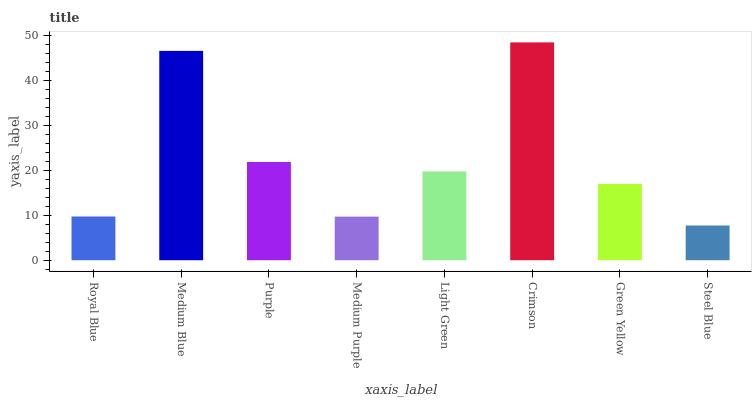Is Medium Blue the minimum?
Answer yes or no. No. Is Medium Blue the maximum?
Answer yes or no. No. Is Medium Blue greater than Royal Blue?
Answer yes or no. Yes. Is Royal Blue less than Medium Blue?
Answer yes or no. Yes. Is Royal Blue greater than Medium Blue?
Answer yes or no. No. Is Medium Blue less than Royal Blue?
Answer yes or no. No. Is Light Green the high median?
Answer yes or no. Yes. Is Green Yellow the low median?
Answer yes or no. Yes. Is Royal Blue the high median?
Answer yes or no. No. Is Light Green the low median?
Answer yes or no. No. 